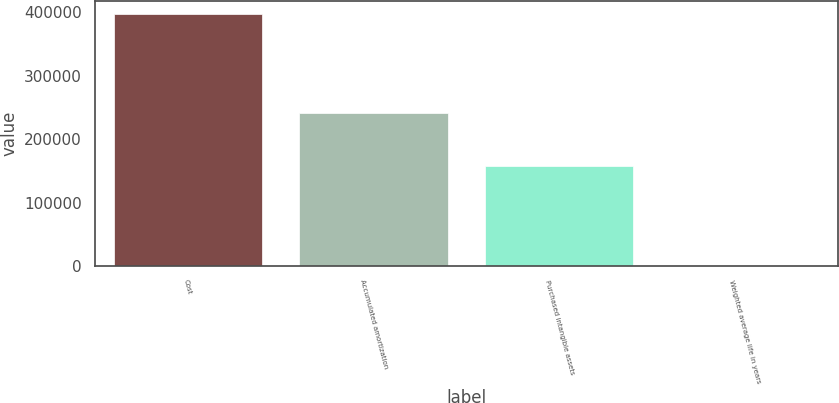<chart> <loc_0><loc_0><loc_500><loc_500><bar_chart><fcel>Cost<fcel>Accumulated amortization<fcel>Purchased intangible assets<fcel>Weighted average life in years<nl><fcel>397356<fcel>240386<fcel>156970<fcel>5<nl></chart> 